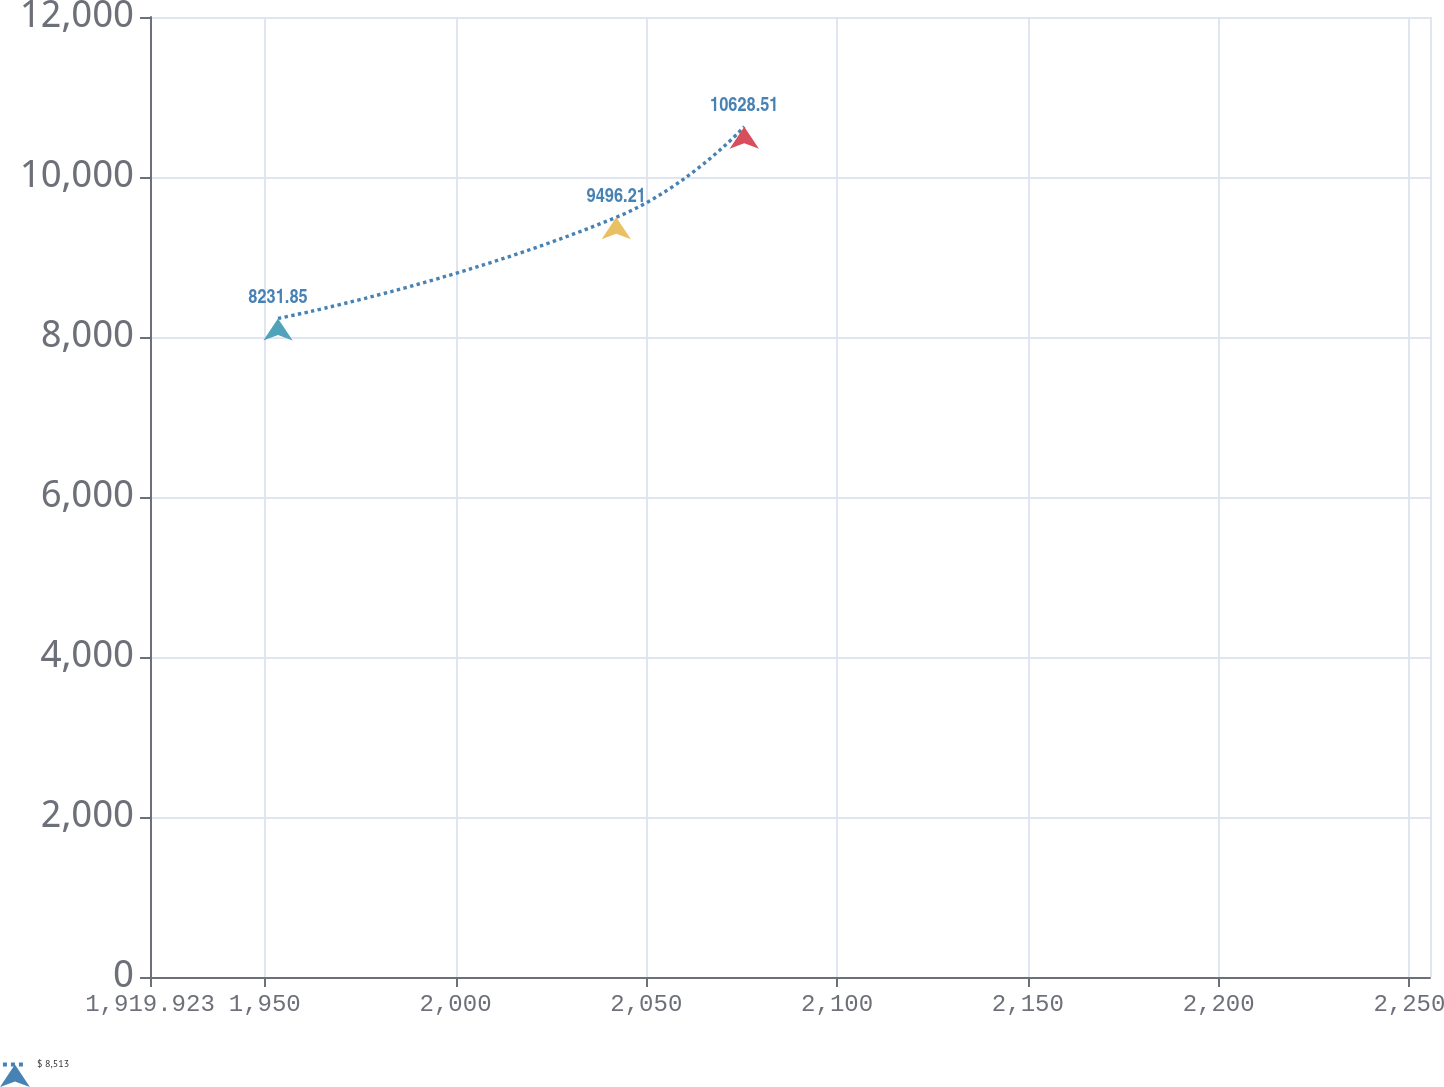<chart> <loc_0><loc_0><loc_500><loc_500><line_chart><ecel><fcel>$ 8,513<nl><fcel>1953.47<fcel>8231.85<nl><fcel>2042.12<fcel>9496.21<nl><fcel>2075.67<fcel>10628.5<nl><fcel>2288.94<fcel>10023.3<nl></chart> 